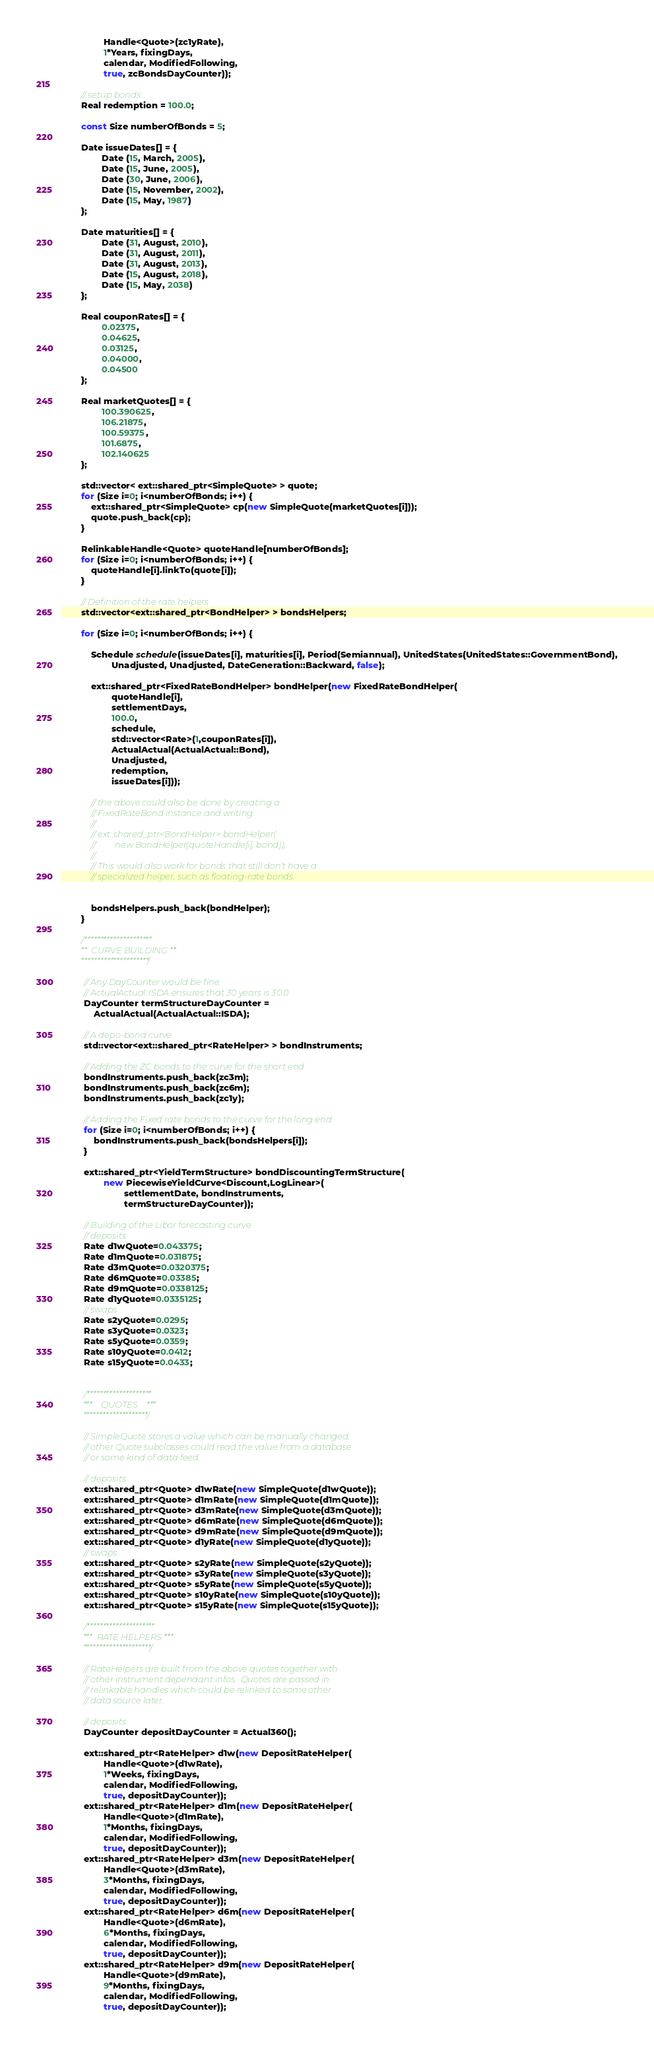<code> <loc_0><loc_0><loc_500><loc_500><_C++_>                 Handle<Quote>(zc1yRate),
                 1*Years, fixingDays,
                 calendar, ModifiedFollowing,
                 true, zcBondsDayCounter));

        // setup bonds
        Real redemption = 100.0;

        const Size numberOfBonds = 5;

        Date issueDates[] = {
                Date (15, March, 2005),
                Date (15, June, 2005),
                Date (30, June, 2006),
                Date (15, November, 2002),
                Date (15, May, 1987)
        };

        Date maturities[] = {
                Date (31, August, 2010),
                Date (31, August, 2011),
                Date (31, August, 2013),
                Date (15, August, 2018),
                Date (15, May, 2038)
        };

        Real couponRates[] = {
                0.02375,
                0.04625,
                0.03125,
                0.04000,
                0.04500
        };

        Real marketQuotes[] = {
                100.390625,
                106.21875,
                100.59375,
                101.6875,
                102.140625
        };

        std::vector< ext::shared_ptr<SimpleQuote> > quote;
        for (Size i=0; i<numberOfBonds; i++) {
            ext::shared_ptr<SimpleQuote> cp(new SimpleQuote(marketQuotes[i]));
            quote.push_back(cp);
        }

        RelinkableHandle<Quote> quoteHandle[numberOfBonds];
        for (Size i=0; i<numberOfBonds; i++) {
            quoteHandle[i].linkTo(quote[i]);
        }

        // Definition of the rate helpers
        std::vector<ext::shared_ptr<BondHelper> > bondsHelpers;

        for (Size i=0; i<numberOfBonds; i++) {

            Schedule schedule(issueDates[i], maturities[i], Period(Semiannual), UnitedStates(UnitedStates::GovernmentBond),
                    Unadjusted, Unadjusted, DateGeneration::Backward, false);

            ext::shared_ptr<FixedRateBondHelper> bondHelper(new FixedRateBondHelper(
                    quoteHandle[i],
                    settlementDays,
                    100.0,
                    schedule,
                    std::vector<Rate>(1,couponRates[i]),
                    ActualActual(ActualActual::Bond),
                    Unadjusted,
                    redemption,
                    issueDates[i]));

            // the above could also be done by creating a
            // FixedRateBond instance and writing:
            //
            // ext::shared_ptr<BondHelper> bondHelper(
            //         new BondHelper(quoteHandle[i], bond));
            //
            // This would also work for bonds that still don't have a
            // specialized helper, such as floating-rate bonds.


            bondsHelpers.push_back(bondHelper);
        }

        /*********************
         **  CURVE BUILDING **
         *********************/

         // Any DayCounter would be fine.
         // ActualActual::ISDA ensures that 30 years is 30.0
         DayCounter termStructureDayCounter =
             ActualActual(ActualActual::ISDA);

         // A depo-bond curve
         std::vector<ext::shared_ptr<RateHelper> > bondInstruments;

         // Adding the ZC bonds to the curve for the short end
         bondInstruments.push_back(zc3m);
         bondInstruments.push_back(zc6m);
         bondInstruments.push_back(zc1y);

         // Adding the Fixed rate bonds to the curve for the long end
         for (Size i=0; i<numberOfBonds; i++) {
             bondInstruments.push_back(bondsHelpers[i]);
         }

         ext::shared_ptr<YieldTermStructure> bondDiscountingTermStructure(
                 new PiecewiseYieldCurve<Discount,LogLinear>(
                         settlementDate, bondInstruments,
                         termStructureDayCounter));

         // Building of the Libor forecasting curve
         // deposits
         Rate d1wQuote=0.043375;
         Rate d1mQuote=0.031875;
         Rate d3mQuote=0.0320375;
         Rate d6mQuote=0.03385;
         Rate d9mQuote=0.0338125;
         Rate d1yQuote=0.0335125;
         // swaps
         Rate s2yQuote=0.0295;
         Rate s3yQuote=0.0323;
         Rate s5yQuote=0.0359;
         Rate s10yQuote=0.0412;
         Rate s15yQuote=0.0433;


         /********************
          ***    QUOTES    ***
          ********************/

         // SimpleQuote stores a value which can be manually changed;
         // other Quote subclasses could read the value from a database
         // or some kind of data feed.

         // deposits
         ext::shared_ptr<Quote> d1wRate(new SimpleQuote(d1wQuote));
         ext::shared_ptr<Quote> d1mRate(new SimpleQuote(d1mQuote));
         ext::shared_ptr<Quote> d3mRate(new SimpleQuote(d3mQuote));
         ext::shared_ptr<Quote> d6mRate(new SimpleQuote(d6mQuote));
         ext::shared_ptr<Quote> d9mRate(new SimpleQuote(d9mQuote));
         ext::shared_ptr<Quote> d1yRate(new SimpleQuote(d1yQuote));
         // swaps
         ext::shared_ptr<Quote> s2yRate(new SimpleQuote(s2yQuote));
         ext::shared_ptr<Quote> s3yRate(new SimpleQuote(s3yQuote));
         ext::shared_ptr<Quote> s5yRate(new SimpleQuote(s5yQuote));
         ext::shared_ptr<Quote> s10yRate(new SimpleQuote(s10yQuote));
         ext::shared_ptr<Quote> s15yRate(new SimpleQuote(s15yQuote));

         /*********************
          ***  RATE HELPERS ***
          *********************/

         // RateHelpers are built from the above quotes together with
         // other instrument dependant infos.  Quotes are passed in
         // relinkable handles which could be relinked to some other
         // data source later.

         // deposits
         DayCounter depositDayCounter = Actual360();

         ext::shared_ptr<RateHelper> d1w(new DepositRateHelper(
                 Handle<Quote>(d1wRate),
                 1*Weeks, fixingDays,
                 calendar, ModifiedFollowing,
                 true, depositDayCounter));
         ext::shared_ptr<RateHelper> d1m(new DepositRateHelper(
                 Handle<Quote>(d1mRate),
                 1*Months, fixingDays,
                 calendar, ModifiedFollowing,
                 true, depositDayCounter));
         ext::shared_ptr<RateHelper> d3m(new DepositRateHelper(
                 Handle<Quote>(d3mRate),
                 3*Months, fixingDays,
                 calendar, ModifiedFollowing,
                 true, depositDayCounter));
         ext::shared_ptr<RateHelper> d6m(new DepositRateHelper(
                 Handle<Quote>(d6mRate),
                 6*Months, fixingDays,
                 calendar, ModifiedFollowing,
                 true, depositDayCounter));
         ext::shared_ptr<RateHelper> d9m(new DepositRateHelper(
                 Handle<Quote>(d9mRate),
                 9*Months, fixingDays,
                 calendar, ModifiedFollowing,
                 true, depositDayCounter));</code> 